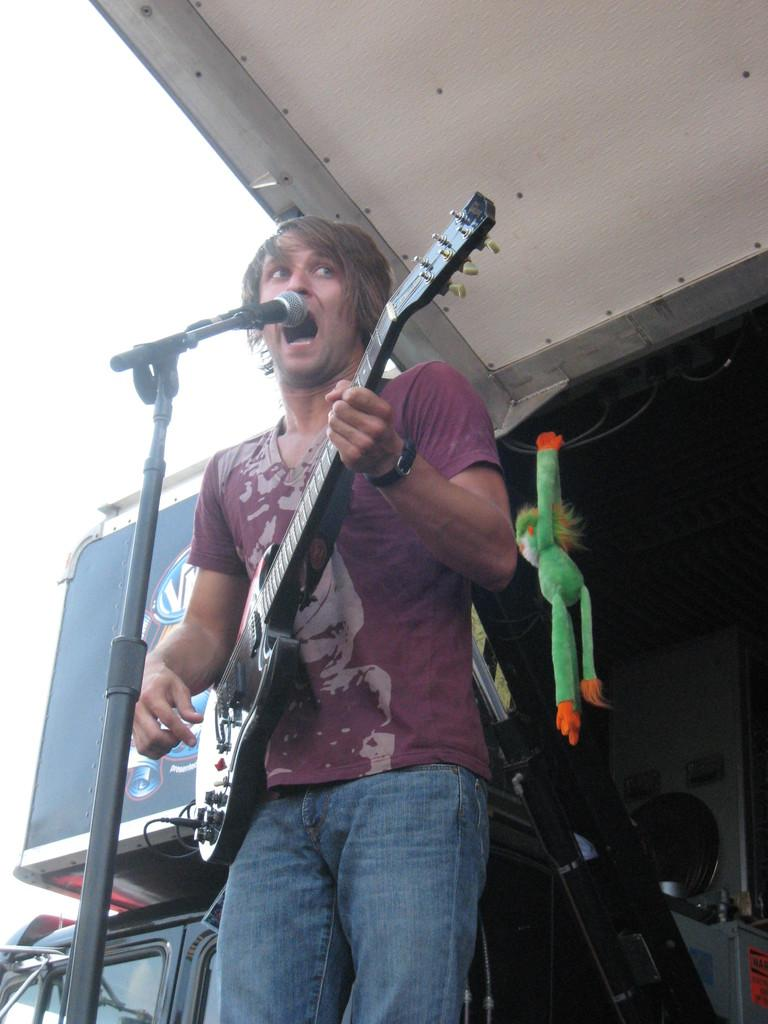What is the person in the image doing? The person is holding a guitar and singing a song. What object is in front of the person? There is a microphone in front of the person. What can be seen hanging in the background? There is a doll hanging in the background. What other items are visible in the background? There are other equipment visible in the background. What type of glass is being used to amplify the person's voice in the image? There is no glass present in the image; the person is using a microphone to amplify their voice. 